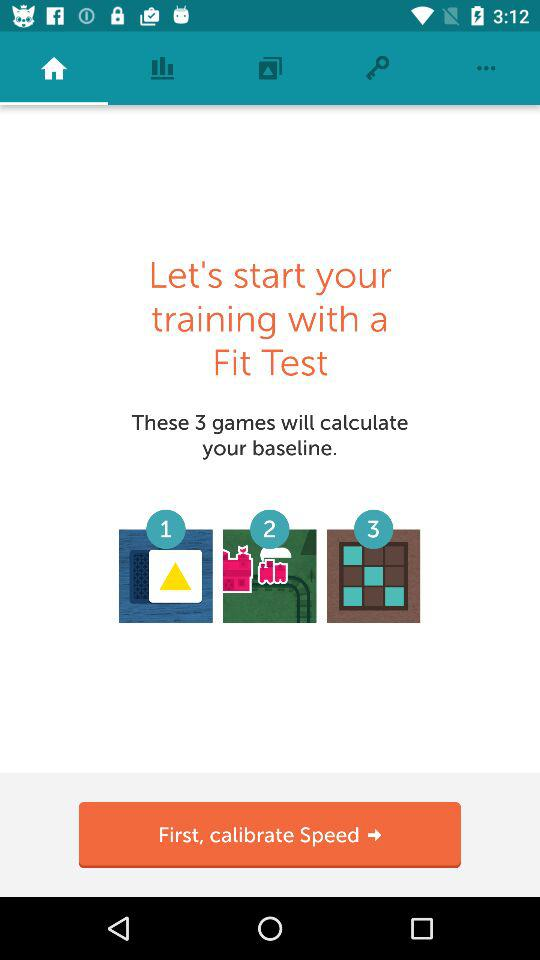Which game option is selected?
When the provided information is insufficient, respond with <no answer>. <no answer> 